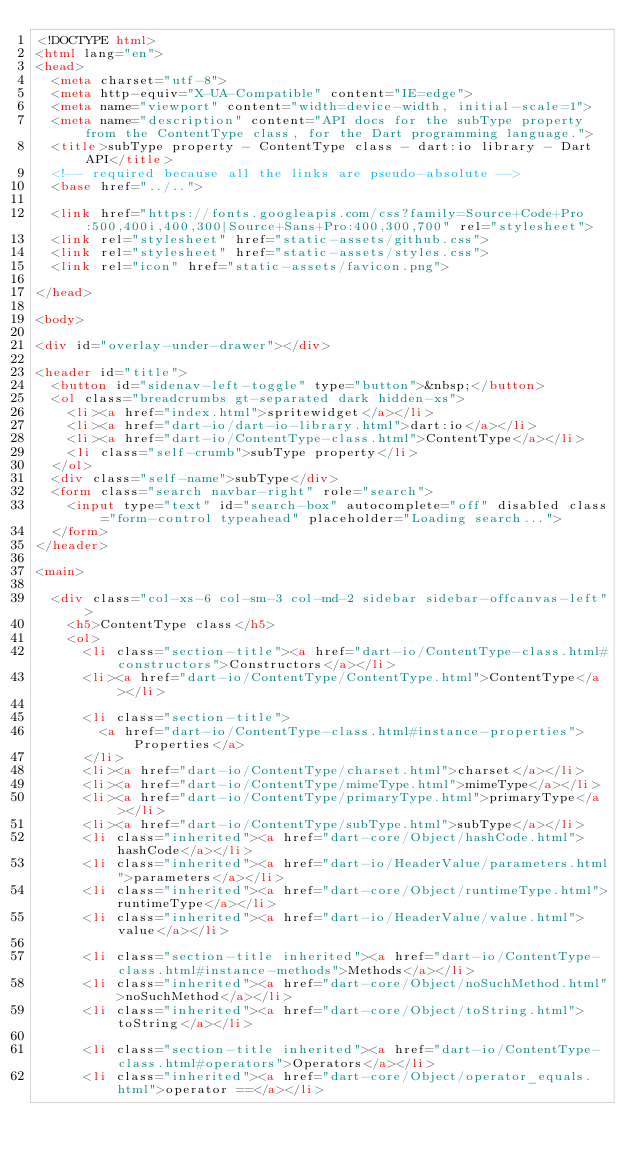Convert code to text. <code><loc_0><loc_0><loc_500><loc_500><_HTML_><!DOCTYPE html>
<html lang="en">
<head>
  <meta charset="utf-8">
  <meta http-equiv="X-UA-Compatible" content="IE=edge">
  <meta name="viewport" content="width=device-width, initial-scale=1">
  <meta name="description" content="API docs for the subType property from the ContentType class, for the Dart programming language.">
  <title>subType property - ContentType class - dart:io library - Dart API</title>
  <!-- required because all the links are pseudo-absolute -->
  <base href="../..">

  <link href="https://fonts.googleapis.com/css?family=Source+Code+Pro:500,400i,400,300|Source+Sans+Pro:400,300,700" rel="stylesheet">
  <link rel="stylesheet" href="static-assets/github.css">
  <link rel="stylesheet" href="static-assets/styles.css">
  <link rel="icon" href="static-assets/favicon.png">

</head>

<body>

<div id="overlay-under-drawer"></div>

<header id="title">
  <button id="sidenav-left-toggle" type="button">&nbsp;</button>
  <ol class="breadcrumbs gt-separated dark hidden-xs">
    <li><a href="index.html">spritewidget</a></li>
    <li><a href="dart-io/dart-io-library.html">dart:io</a></li>
    <li><a href="dart-io/ContentType-class.html">ContentType</a></li>
    <li class="self-crumb">subType property</li>
  </ol>
  <div class="self-name">subType</div>
  <form class="search navbar-right" role="search">
    <input type="text" id="search-box" autocomplete="off" disabled class="form-control typeahead" placeholder="Loading search...">
  </form>
</header>

<main>

  <div class="col-xs-6 col-sm-3 col-md-2 sidebar sidebar-offcanvas-left">
    <h5>ContentType class</h5>
    <ol>
      <li class="section-title"><a href="dart-io/ContentType-class.html#constructors">Constructors</a></li>
      <li><a href="dart-io/ContentType/ContentType.html">ContentType</a></li>
    
      <li class="section-title">
        <a href="dart-io/ContentType-class.html#instance-properties">Properties</a>
      </li>
      <li><a href="dart-io/ContentType/charset.html">charset</a></li>
      <li><a href="dart-io/ContentType/mimeType.html">mimeType</a></li>
      <li><a href="dart-io/ContentType/primaryType.html">primaryType</a></li>
      <li><a href="dart-io/ContentType/subType.html">subType</a></li>
      <li class="inherited"><a href="dart-core/Object/hashCode.html">hashCode</a></li>
      <li class="inherited"><a href="dart-io/HeaderValue/parameters.html">parameters</a></li>
      <li class="inherited"><a href="dart-core/Object/runtimeType.html">runtimeType</a></li>
      <li class="inherited"><a href="dart-io/HeaderValue/value.html">value</a></li>
    
      <li class="section-title inherited"><a href="dart-io/ContentType-class.html#instance-methods">Methods</a></li>
      <li class="inherited"><a href="dart-core/Object/noSuchMethod.html">noSuchMethod</a></li>
      <li class="inherited"><a href="dart-core/Object/toString.html">toString</a></li>
    
      <li class="section-title inherited"><a href="dart-io/ContentType-class.html#operators">Operators</a></li>
      <li class="inherited"><a href="dart-core/Object/operator_equals.html">operator ==</a></li>
    </code> 